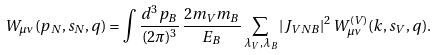<formula> <loc_0><loc_0><loc_500><loc_500>W _ { \mu \nu } ( p _ { N } , s _ { N } , q ) = \int \frac { d ^ { 3 } p _ { B } } { ( 2 \pi ) ^ { 3 } } \, \frac { 2 m _ { V } m _ { B } } { E _ { B } } \sum _ { \lambda _ { V } , \lambda _ { B } } | J _ { V N B } | ^ { 2 } \, W _ { \mu \nu } ^ { ( V ) } ( k , s _ { V } , q ) .</formula> 